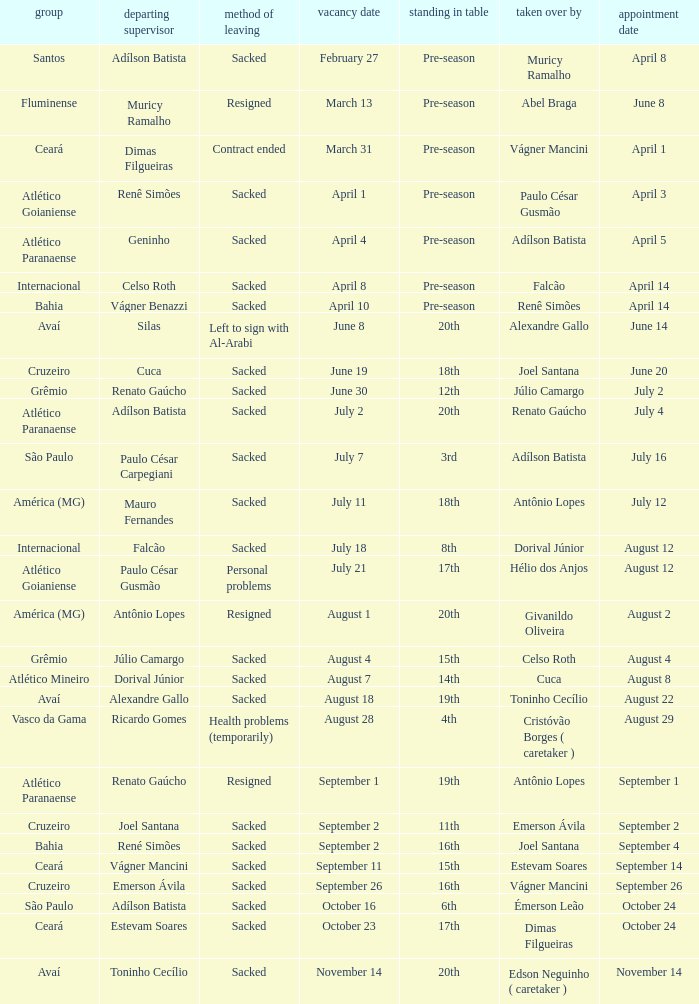How many times did Silas leave as a team manager? 1.0. 